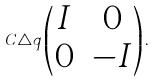Convert formula to latex. <formula><loc_0><loc_0><loc_500><loc_500>C \triangle q \begin{pmatrix} I & 0 \\ 0 & - I \end{pmatrix} .</formula> 